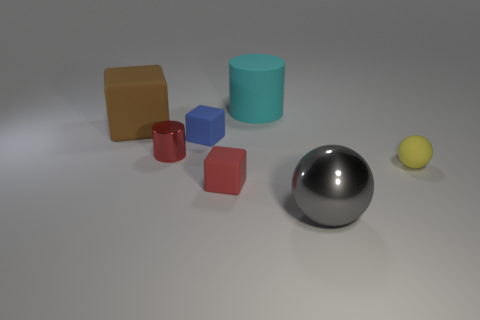Add 3 tiny blue blocks. How many objects exist? 10 Subtract all cylinders. How many objects are left? 5 Subtract 1 gray spheres. How many objects are left? 6 Subtract all big matte cylinders. Subtract all gray shiny spheres. How many objects are left? 5 Add 2 large gray things. How many large gray things are left? 3 Add 5 small yellow spheres. How many small yellow spheres exist? 6 